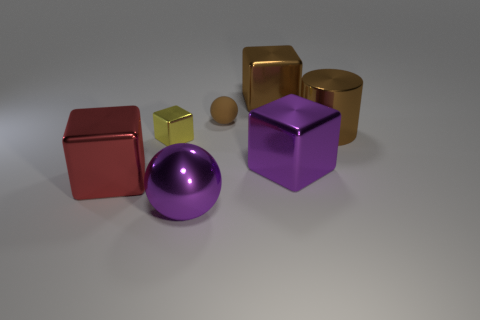What shape is the big brown object that is the same material as the cylinder?
Keep it short and to the point. Cube. Are there any other things that are the same shape as the big red metal object?
Provide a succinct answer. Yes. What color is the big object that is both right of the brown metallic cube and in front of the tiny yellow metal object?
Offer a very short reply. Purple. How many cubes are large brown things or brown things?
Your answer should be very brief. 1. What number of cubes are the same size as the brown matte sphere?
Your answer should be compact. 1. What number of tiny brown balls are behind the brown metal thing that is in front of the brown shiny block?
Offer a terse response. 1. What size is the object that is both behind the large purple metal block and left of the small rubber object?
Provide a succinct answer. Small. Is the number of yellow metal cubes greater than the number of cyan objects?
Your answer should be compact. Yes. Is there a big matte sphere of the same color as the large metal sphere?
Ensure brevity in your answer.  No. Do the ball in front of the purple block and the big red object have the same size?
Provide a succinct answer. Yes. 